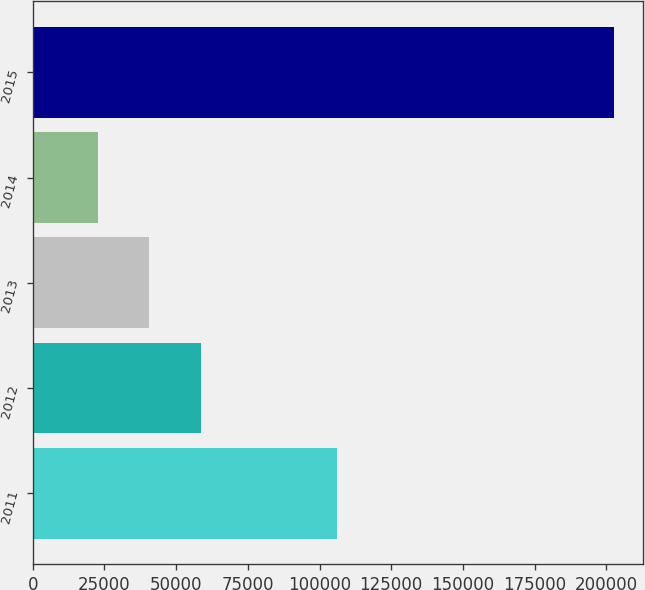<chart> <loc_0><loc_0><loc_500><loc_500><bar_chart><fcel>2011<fcel>2012<fcel>2013<fcel>2014<fcel>2015<nl><fcel>105963<fcel>58660.2<fcel>40678.1<fcel>22696<fcel>202517<nl></chart> 